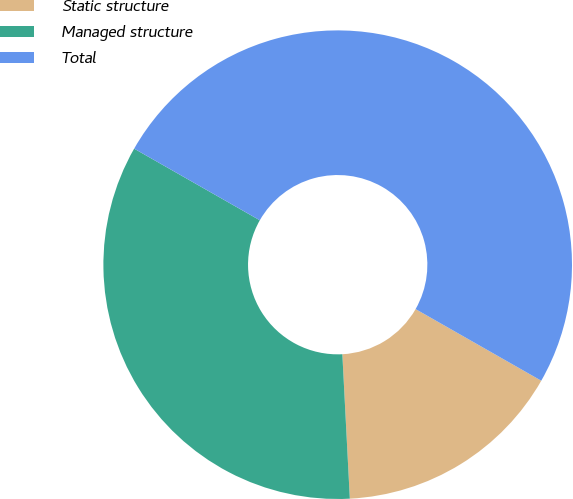Convert chart. <chart><loc_0><loc_0><loc_500><loc_500><pie_chart><fcel>Static structure<fcel>Managed structure<fcel>Total<nl><fcel>15.93%<fcel>34.07%<fcel>50.0%<nl></chart> 